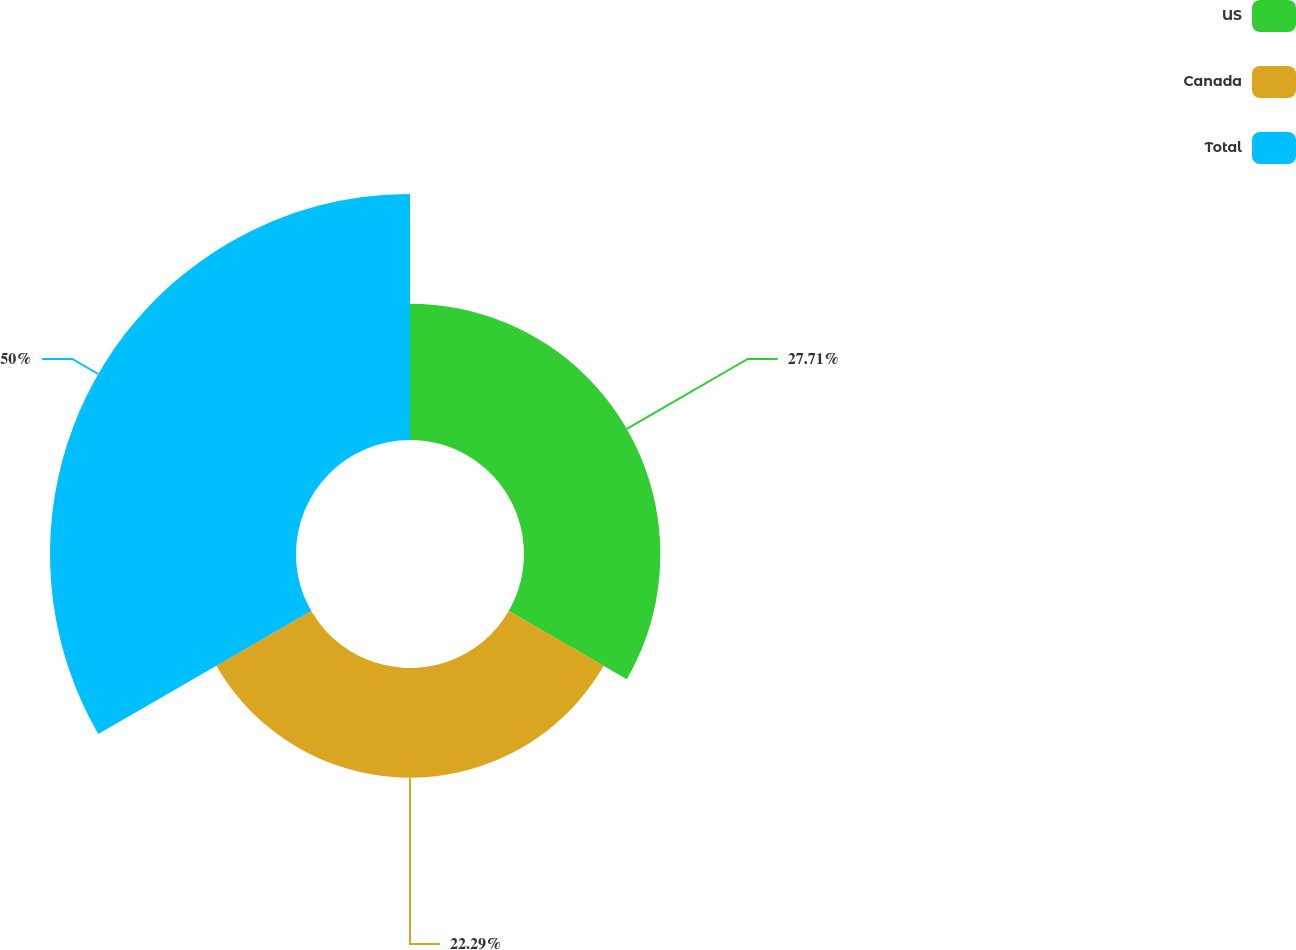Convert chart to OTSL. <chart><loc_0><loc_0><loc_500><loc_500><pie_chart><fcel>US<fcel>Canada<fcel>Total<nl><fcel>27.71%<fcel>22.29%<fcel>50.0%<nl></chart> 